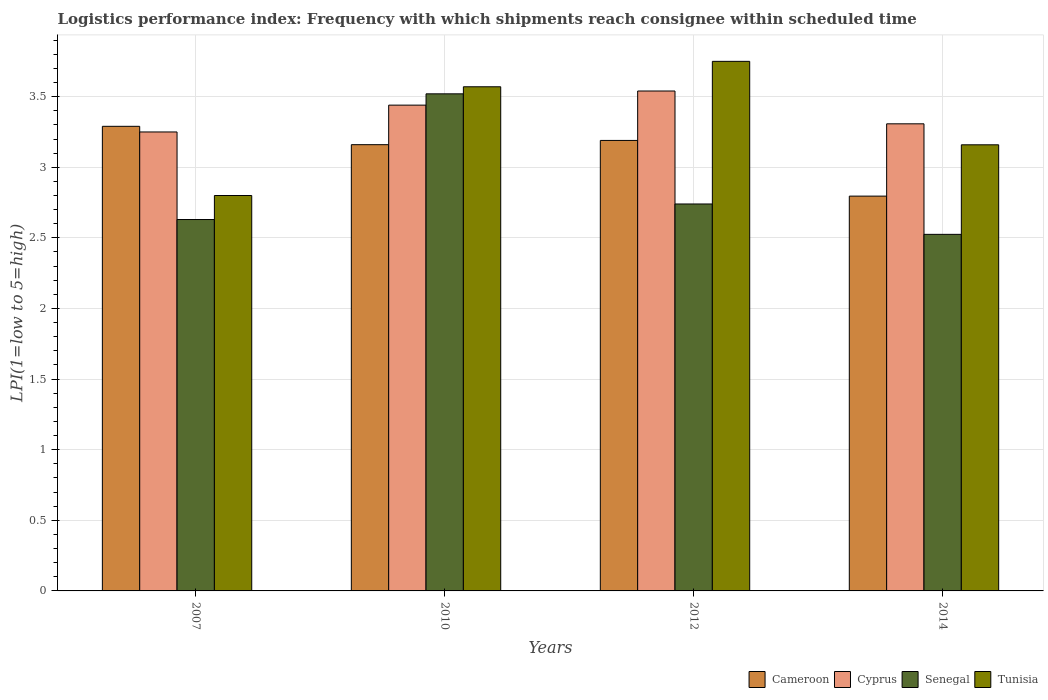How many groups of bars are there?
Give a very brief answer. 4. Are the number of bars on each tick of the X-axis equal?
Offer a very short reply. Yes. How many bars are there on the 1st tick from the left?
Keep it short and to the point. 4. What is the logistics performance index in Tunisia in 2012?
Offer a terse response. 3.75. Across all years, what is the maximum logistics performance index in Cameroon?
Keep it short and to the point. 3.29. Across all years, what is the minimum logistics performance index in Cyprus?
Keep it short and to the point. 3.25. What is the total logistics performance index in Senegal in the graph?
Offer a terse response. 11.42. What is the difference between the logistics performance index in Senegal in 2007 and that in 2014?
Provide a short and direct response. 0.1. What is the difference between the logistics performance index in Tunisia in 2014 and the logistics performance index in Cyprus in 2012?
Ensure brevity in your answer.  -0.38. What is the average logistics performance index in Senegal per year?
Your response must be concise. 2.85. In the year 2014, what is the difference between the logistics performance index in Tunisia and logistics performance index in Cyprus?
Make the answer very short. -0.15. What is the ratio of the logistics performance index in Senegal in 2010 to that in 2014?
Provide a succinct answer. 1.39. Is the logistics performance index in Cameroon in 2012 less than that in 2014?
Your answer should be very brief. No. Is the difference between the logistics performance index in Tunisia in 2010 and 2014 greater than the difference between the logistics performance index in Cyprus in 2010 and 2014?
Offer a terse response. Yes. What is the difference between the highest and the second highest logistics performance index in Cyprus?
Ensure brevity in your answer.  0.1. What is the difference between the highest and the lowest logistics performance index in Cameroon?
Offer a very short reply. 0.49. Is the sum of the logistics performance index in Senegal in 2007 and 2010 greater than the maximum logistics performance index in Cyprus across all years?
Your answer should be very brief. Yes. What does the 1st bar from the left in 2014 represents?
Offer a very short reply. Cameroon. What does the 2nd bar from the right in 2010 represents?
Your response must be concise. Senegal. Is it the case that in every year, the sum of the logistics performance index in Tunisia and logistics performance index in Cyprus is greater than the logistics performance index in Senegal?
Offer a terse response. Yes. Are all the bars in the graph horizontal?
Provide a short and direct response. No. How many years are there in the graph?
Give a very brief answer. 4. What is the difference between two consecutive major ticks on the Y-axis?
Your answer should be compact. 0.5. Does the graph contain any zero values?
Offer a terse response. No. What is the title of the graph?
Offer a very short reply. Logistics performance index: Frequency with which shipments reach consignee within scheduled time. Does "Algeria" appear as one of the legend labels in the graph?
Your answer should be compact. No. What is the label or title of the X-axis?
Ensure brevity in your answer.  Years. What is the label or title of the Y-axis?
Your answer should be compact. LPI(1=low to 5=high). What is the LPI(1=low to 5=high) of Cameroon in 2007?
Provide a short and direct response. 3.29. What is the LPI(1=low to 5=high) of Senegal in 2007?
Provide a short and direct response. 2.63. What is the LPI(1=low to 5=high) in Cameroon in 2010?
Your answer should be very brief. 3.16. What is the LPI(1=low to 5=high) in Cyprus in 2010?
Give a very brief answer. 3.44. What is the LPI(1=low to 5=high) of Senegal in 2010?
Your response must be concise. 3.52. What is the LPI(1=low to 5=high) in Tunisia in 2010?
Your answer should be compact. 3.57. What is the LPI(1=low to 5=high) of Cameroon in 2012?
Your answer should be very brief. 3.19. What is the LPI(1=low to 5=high) in Cyprus in 2012?
Your answer should be very brief. 3.54. What is the LPI(1=low to 5=high) of Senegal in 2012?
Offer a very short reply. 2.74. What is the LPI(1=low to 5=high) of Tunisia in 2012?
Provide a succinct answer. 3.75. What is the LPI(1=low to 5=high) in Cameroon in 2014?
Offer a very short reply. 2.8. What is the LPI(1=low to 5=high) in Cyprus in 2014?
Keep it short and to the point. 3.31. What is the LPI(1=low to 5=high) of Senegal in 2014?
Give a very brief answer. 2.52. What is the LPI(1=low to 5=high) of Tunisia in 2014?
Ensure brevity in your answer.  3.16. Across all years, what is the maximum LPI(1=low to 5=high) of Cameroon?
Your answer should be very brief. 3.29. Across all years, what is the maximum LPI(1=low to 5=high) in Cyprus?
Give a very brief answer. 3.54. Across all years, what is the maximum LPI(1=low to 5=high) in Senegal?
Offer a terse response. 3.52. Across all years, what is the maximum LPI(1=low to 5=high) of Tunisia?
Your answer should be very brief. 3.75. Across all years, what is the minimum LPI(1=low to 5=high) in Cameroon?
Provide a succinct answer. 2.8. Across all years, what is the minimum LPI(1=low to 5=high) in Senegal?
Ensure brevity in your answer.  2.52. What is the total LPI(1=low to 5=high) in Cameroon in the graph?
Provide a short and direct response. 12.44. What is the total LPI(1=low to 5=high) of Cyprus in the graph?
Offer a very short reply. 13.54. What is the total LPI(1=low to 5=high) of Senegal in the graph?
Your answer should be compact. 11.41. What is the total LPI(1=low to 5=high) in Tunisia in the graph?
Keep it short and to the point. 13.28. What is the difference between the LPI(1=low to 5=high) in Cameroon in 2007 and that in 2010?
Provide a short and direct response. 0.13. What is the difference between the LPI(1=low to 5=high) in Cyprus in 2007 and that in 2010?
Your response must be concise. -0.19. What is the difference between the LPI(1=low to 5=high) of Senegal in 2007 and that in 2010?
Offer a terse response. -0.89. What is the difference between the LPI(1=low to 5=high) of Tunisia in 2007 and that in 2010?
Your response must be concise. -0.77. What is the difference between the LPI(1=low to 5=high) of Cyprus in 2007 and that in 2012?
Ensure brevity in your answer.  -0.29. What is the difference between the LPI(1=low to 5=high) of Senegal in 2007 and that in 2012?
Provide a short and direct response. -0.11. What is the difference between the LPI(1=low to 5=high) of Tunisia in 2007 and that in 2012?
Your answer should be very brief. -0.95. What is the difference between the LPI(1=low to 5=high) in Cameroon in 2007 and that in 2014?
Make the answer very short. 0.49. What is the difference between the LPI(1=low to 5=high) of Cyprus in 2007 and that in 2014?
Give a very brief answer. -0.06. What is the difference between the LPI(1=low to 5=high) in Senegal in 2007 and that in 2014?
Offer a very short reply. 0.1. What is the difference between the LPI(1=low to 5=high) in Tunisia in 2007 and that in 2014?
Provide a short and direct response. -0.36. What is the difference between the LPI(1=low to 5=high) of Cameroon in 2010 and that in 2012?
Your response must be concise. -0.03. What is the difference between the LPI(1=low to 5=high) in Senegal in 2010 and that in 2012?
Ensure brevity in your answer.  0.78. What is the difference between the LPI(1=low to 5=high) of Tunisia in 2010 and that in 2012?
Your response must be concise. -0.18. What is the difference between the LPI(1=low to 5=high) in Cameroon in 2010 and that in 2014?
Offer a very short reply. 0.36. What is the difference between the LPI(1=low to 5=high) of Cyprus in 2010 and that in 2014?
Offer a terse response. 0.13. What is the difference between the LPI(1=low to 5=high) of Senegal in 2010 and that in 2014?
Your answer should be very brief. 0.99. What is the difference between the LPI(1=low to 5=high) in Tunisia in 2010 and that in 2014?
Give a very brief answer. 0.41. What is the difference between the LPI(1=low to 5=high) in Cameroon in 2012 and that in 2014?
Provide a short and direct response. 0.39. What is the difference between the LPI(1=low to 5=high) in Cyprus in 2012 and that in 2014?
Provide a succinct answer. 0.23. What is the difference between the LPI(1=low to 5=high) in Senegal in 2012 and that in 2014?
Provide a short and direct response. 0.21. What is the difference between the LPI(1=low to 5=high) of Tunisia in 2012 and that in 2014?
Offer a terse response. 0.59. What is the difference between the LPI(1=low to 5=high) of Cameroon in 2007 and the LPI(1=low to 5=high) of Senegal in 2010?
Ensure brevity in your answer.  -0.23. What is the difference between the LPI(1=low to 5=high) of Cameroon in 2007 and the LPI(1=low to 5=high) of Tunisia in 2010?
Provide a short and direct response. -0.28. What is the difference between the LPI(1=low to 5=high) in Cyprus in 2007 and the LPI(1=low to 5=high) in Senegal in 2010?
Keep it short and to the point. -0.27. What is the difference between the LPI(1=low to 5=high) of Cyprus in 2007 and the LPI(1=low to 5=high) of Tunisia in 2010?
Your answer should be compact. -0.32. What is the difference between the LPI(1=low to 5=high) of Senegal in 2007 and the LPI(1=low to 5=high) of Tunisia in 2010?
Offer a very short reply. -0.94. What is the difference between the LPI(1=low to 5=high) of Cameroon in 2007 and the LPI(1=low to 5=high) of Cyprus in 2012?
Give a very brief answer. -0.25. What is the difference between the LPI(1=low to 5=high) of Cameroon in 2007 and the LPI(1=low to 5=high) of Senegal in 2012?
Offer a terse response. 0.55. What is the difference between the LPI(1=low to 5=high) in Cameroon in 2007 and the LPI(1=low to 5=high) in Tunisia in 2012?
Provide a short and direct response. -0.46. What is the difference between the LPI(1=low to 5=high) of Cyprus in 2007 and the LPI(1=low to 5=high) of Senegal in 2012?
Provide a succinct answer. 0.51. What is the difference between the LPI(1=low to 5=high) of Cyprus in 2007 and the LPI(1=low to 5=high) of Tunisia in 2012?
Offer a terse response. -0.5. What is the difference between the LPI(1=low to 5=high) in Senegal in 2007 and the LPI(1=low to 5=high) in Tunisia in 2012?
Give a very brief answer. -1.12. What is the difference between the LPI(1=low to 5=high) of Cameroon in 2007 and the LPI(1=low to 5=high) of Cyprus in 2014?
Your answer should be very brief. -0.02. What is the difference between the LPI(1=low to 5=high) of Cameroon in 2007 and the LPI(1=low to 5=high) of Senegal in 2014?
Keep it short and to the point. 0.77. What is the difference between the LPI(1=low to 5=high) in Cameroon in 2007 and the LPI(1=low to 5=high) in Tunisia in 2014?
Offer a terse response. 0.13. What is the difference between the LPI(1=low to 5=high) in Cyprus in 2007 and the LPI(1=low to 5=high) in Senegal in 2014?
Your response must be concise. 0.72. What is the difference between the LPI(1=low to 5=high) of Cyprus in 2007 and the LPI(1=low to 5=high) of Tunisia in 2014?
Provide a short and direct response. 0.09. What is the difference between the LPI(1=low to 5=high) of Senegal in 2007 and the LPI(1=low to 5=high) of Tunisia in 2014?
Your answer should be very brief. -0.53. What is the difference between the LPI(1=low to 5=high) in Cameroon in 2010 and the LPI(1=low to 5=high) in Cyprus in 2012?
Provide a succinct answer. -0.38. What is the difference between the LPI(1=low to 5=high) of Cameroon in 2010 and the LPI(1=low to 5=high) of Senegal in 2012?
Ensure brevity in your answer.  0.42. What is the difference between the LPI(1=low to 5=high) in Cameroon in 2010 and the LPI(1=low to 5=high) in Tunisia in 2012?
Keep it short and to the point. -0.59. What is the difference between the LPI(1=low to 5=high) in Cyprus in 2010 and the LPI(1=low to 5=high) in Senegal in 2012?
Keep it short and to the point. 0.7. What is the difference between the LPI(1=low to 5=high) in Cyprus in 2010 and the LPI(1=low to 5=high) in Tunisia in 2012?
Your answer should be compact. -0.31. What is the difference between the LPI(1=low to 5=high) in Senegal in 2010 and the LPI(1=low to 5=high) in Tunisia in 2012?
Offer a very short reply. -0.23. What is the difference between the LPI(1=low to 5=high) in Cameroon in 2010 and the LPI(1=low to 5=high) in Cyprus in 2014?
Give a very brief answer. -0.15. What is the difference between the LPI(1=low to 5=high) in Cameroon in 2010 and the LPI(1=low to 5=high) in Senegal in 2014?
Give a very brief answer. 0.64. What is the difference between the LPI(1=low to 5=high) of Cyprus in 2010 and the LPI(1=low to 5=high) of Senegal in 2014?
Ensure brevity in your answer.  0.92. What is the difference between the LPI(1=low to 5=high) of Cyprus in 2010 and the LPI(1=low to 5=high) of Tunisia in 2014?
Ensure brevity in your answer.  0.28. What is the difference between the LPI(1=low to 5=high) of Senegal in 2010 and the LPI(1=low to 5=high) of Tunisia in 2014?
Offer a very short reply. 0.36. What is the difference between the LPI(1=low to 5=high) in Cameroon in 2012 and the LPI(1=low to 5=high) in Cyprus in 2014?
Ensure brevity in your answer.  -0.12. What is the difference between the LPI(1=low to 5=high) of Cameroon in 2012 and the LPI(1=low to 5=high) of Senegal in 2014?
Offer a terse response. 0.67. What is the difference between the LPI(1=low to 5=high) in Cameroon in 2012 and the LPI(1=low to 5=high) in Tunisia in 2014?
Your response must be concise. 0.03. What is the difference between the LPI(1=low to 5=high) in Cyprus in 2012 and the LPI(1=low to 5=high) in Tunisia in 2014?
Offer a terse response. 0.38. What is the difference between the LPI(1=low to 5=high) of Senegal in 2012 and the LPI(1=low to 5=high) of Tunisia in 2014?
Your answer should be very brief. -0.42. What is the average LPI(1=low to 5=high) in Cameroon per year?
Provide a short and direct response. 3.11. What is the average LPI(1=low to 5=high) in Cyprus per year?
Your response must be concise. 3.38. What is the average LPI(1=low to 5=high) in Senegal per year?
Your answer should be very brief. 2.85. What is the average LPI(1=low to 5=high) of Tunisia per year?
Your answer should be very brief. 3.32. In the year 2007, what is the difference between the LPI(1=low to 5=high) in Cameroon and LPI(1=low to 5=high) in Senegal?
Make the answer very short. 0.66. In the year 2007, what is the difference between the LPI(1=low to 5=high) in Cameroon and LPI(1=low to 5=high) in Tunisia?
Provide a short and direct response. 0.49. In the year 2007, what is the difference between the LPI(1=low to 5=high) of Cyprus and LPI(1=low to 5=high) of Senegal?
Make the answer very short. 0.62. In the year 2007, what is the difference between the LPI(1=low to 5=high) of Cyprus and LPI(1=low to 5=high) of Tunisia?
Give a very brief answer. 0.45. In the year 2007, what is the difference between the LPI(1=low to 5=high) of Senegal and LPI(1=low to 5=high) of Tunisia?
Provide a short and direct response. -0.17. In the year 2010, what is the difference between the LPI(1=low to 5=high) of Cameroon and LPI(1=low to 5=high) of Cyprus?
Provide a short and direct response. -0.28. In the year 2010, what is the difference between the LPI(1=low to 5=high) of Cameroon and LPI(1=low to 5=high) of Senegal?
Provide a succinct answer. -0.36. In the year 2010, what is the difference between the LPI(1=low to 5=high) in Cameroon and LPI(1=low to 5=high) in Tunisia?
Make the answer very short. -0.41. In the year 2010, what is the difference between the LPI(1=low to 5=high) in Cyprus and LPI(1=low to 5=high) in Senegal?
Give a very brief answer. -0.08. In the year 2010, what is the difference between the LPI(1=low to 5=high) of Cyprus and LPI(1=low to 5=high) of Tunisia?
Your answer should be compact. -0.13. In the year 2012, what is the difference between the LPI(1=low to 5=high) in Cameroon and LPI(1=low to 5=high) in Cyprus?
Keep it short and to the point. -0.35. In the year 2012, what is the difference between the LPI(1=low to 5=high) of Cameroon and LPI(1=low to 5=high) of Senegal?
Keep it short and to the point. 0.45. In the year 2012, what is the difference between the LPI(1=low to 5=high) in Cameroon and LPI(1=low to 5=high) in Tunisia?
Make the answer very short. -0.56. In the year 2012, what is the difference between the LPI(1=low to 5=high) of Cyprus and LPI(1=low to 5=high) of Senegal?
Ensure brevity in your answer.  0.8. In the year 2012, what is the difference between the LPI(1=low to 5=high) of Cyprus and LPI(1=low to 5=high) of Tunisia?
Provide a short and direct response. -0.21. In the year 2012, what is the difference between the LPI(1=low to 5=high) in Senegal and LPI(1=low to 5=high) in Tunisia?
Keep it short and to the point. -1.01. In the year 2014, what is the difference between the LPI(1=low to 5=high) in Cameroon and LPI(1=low to 5=high) in Cyprus?
Offer a very short reply. -0.51. In the year 2014, what is the difference between the LPI(1=low to 5=high) of Cameroon and LPI(1=low to 5=high) of Senegal?
Keep it short and to the point. 0.27. In the year 2014, what is the difference between the LPI(1=low to 5=high) in Cameroon and LPI(1=low to 5=high) in Tunisia?
Your answer should be very brief. -0.36. In the year 2014, what is the difference between the LPI(1=low to 5=high) in Cyprus and LPI(1=low to 5=high) in Senegal?
Offer a very short reply. 0.78. In the year 2014, what is the difference between the LPI(1=low to 5=high) of Cyprus and LPI(1=low to 5=high) of Tunisia?
Offer a very short reply. 0.15. In the year 2014, what is the difference between the LPI(1=low to 5=high) in Senegal and LPI(1=low to 5=high) in Tunisia?
Ensure brevity in your answer.  -0.63. What is the ratio of the LPI(1=low to 5=high) in Cameroon in 2007 to that in 2010?
Your answer should be very brief. 1.04. What is the ratio of the LPI(1=low to 5=high) of Cyprus in 2007 to that in 2010?
Keep it short and to the point. 0.94. What is the ratio of the LPI(1=low to 5=high) of Senegal in 2007 to that in 2010?
Your response must be concise. 0.75. What is the ratio of the LPI(1=low to 5=high) in Tunisia in 2007 to that in 2010?
Make the answer very short. 0.78. What is the ratio of the LPI(1=low to 5=high) in Cameroon in 2007 to that in 2012?
Offer a very short reply. 1.03. What is the ratio of the LPI(1=low to 5=high) in Cyprus in 2007 to that in 2012?
Provide a short and direct response. 0.92. What is the ratio of the LPI(1=low to 5=high) in Senegal in 2007 to that in 2012?
Your answer should be compact. 0.96. What is the ratio of the LPI(1=low to 5=high) of Tunisia in 2007 to that in 2012?
Offer a very short reply. 0.75. What is the ratio of the LPI(1=low to 5=high) in Cameroon in 2007 to that in 2014?
Offer a very short reply. 1.18. What is the ratio of the LPI(1=low to 5=high) in Cyprus in 2007 to that in 2014?
Offer a terse response. 0.98. What is the ratio of the LPI(1=low to 5=high) in Senegal in 2007 to that in 2014?
Make the answer very short. 1.04. What is the ratio of the LPI(1=low to 5=high) in Tunisia in 2007 to that in 2014?
Offer a very short reply. 0.89. What is the ratio of the LPI(1=low to 5=high) in Cameroon in 2010 to that in 2012?
Provide a short and direct response. 0.99. What is the ratio of the LPI(1=low to 5=high) of Cyprus in 2010 to that in 2012?
Provide a succinct answer. 0.97. What is the ratio of the LPI(1=low to 5=high) of Senegal in 2010 to that in 2012?
Ensure brevity in your answer.  1.28. What is the ratio of the LPI(1=low to 5=high) of Tunisia in 2010 to that in 2012?
Keep it short and to the point. 0.95. What is the ratio of the LPI(1=low to 5=high) in Cameroon in 2010 to that in 2014?
Your answer should be compact. 1.13. What is the ratio of the LPI(1=low to 5=high) of Senegal in 2010 to that in 2014?
Your response must be concise. 1.39. What is the ratio of the LPI(1=low to 5=high) of Tunisia in 2010 to that in 2014?
Your answer should be very brief. 1.13. What is the ratio of the LPI(1=low to 5=high) in Cameroon in 2012 to that in 2014?
Offer a very short reply. 1.14. What is the ratio of the LPI(1=low to 5=high) in Cyprus in 2012 to that in 2014?
Keep it short and to the point. 1.07. What is the ratio of the LPI(1=low to 5=high) of Senegal in 2012 to that in 2014?
Your answer should be compact. 1.09. What is the ratio of the LPI(1=low to 5=high) in Tunisia in 2012 to that in 2014?
Keep it short and to the point. 1.19. What is the difference between the highest and the second highest LPI(1=low to 5=high) in Cyprus?
Your answer should be compact. 0.1. What is the difference between the highest and the second highest LPI(1=low to 5=high) of Senegal?
Your answer should be compact. 0.78. What is the difference between the highest and the second highest LPI(1=low to 5=high) in Tunisia?
Ensure brevity in your answer.  0.18. What is the difference between the highest and the lowest LPI(1=low to 5=high) in Cameroon?
Ensure brevity in your answer.  0.49. What is the difference between the highest and the lowest LPI(1=low to 5=high) of Cyprus?
Offer a very short reply. 0.29. What is the difference between the highest and the lowest LPI(1=low to 5=high) of Tunisia?
Ensure brevity in your answer.  0.95. 